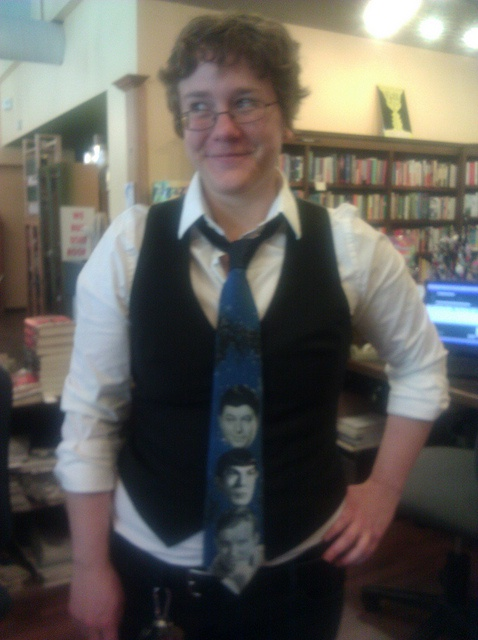Describe the objects in this image and their specific colors. I can see people in darkgray, black, and gray tones, book in darkgray, black, and gray tones, tie in darkgray, black, gray, navy, and blue tones, chair in darkgray and black tones, and book in darkgray, gray, tan, and darkgreen tones in this image. 